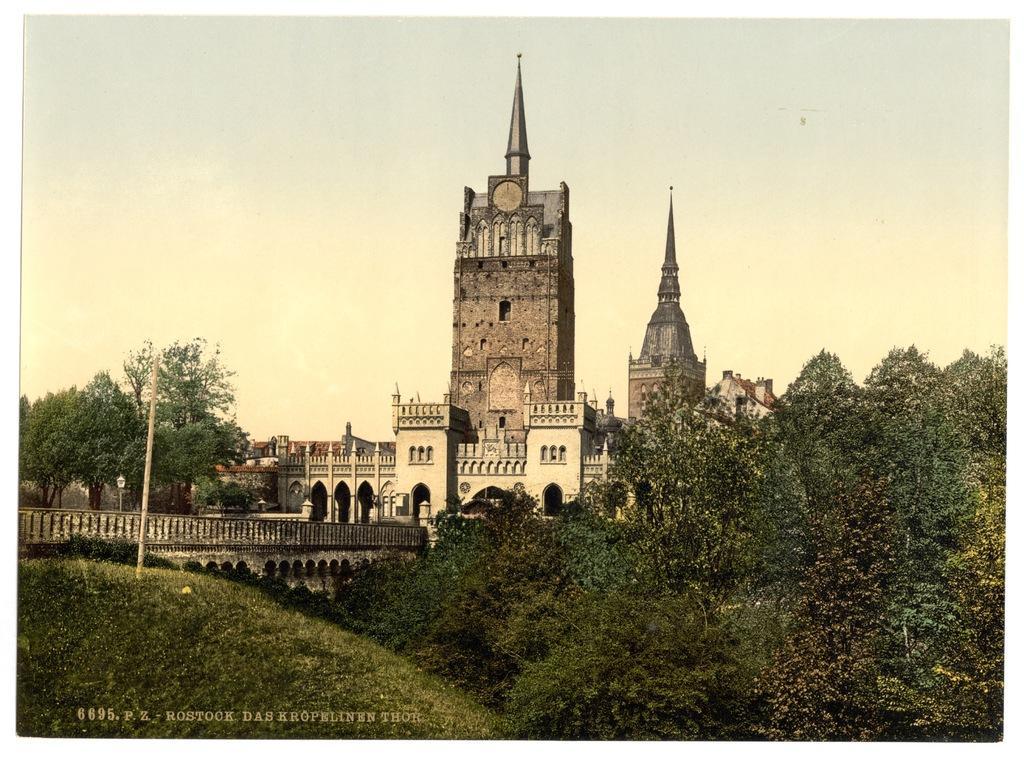Can you describe this image briefly? In this image we can see the buildings, there are some trees, poles and grass on the ground, also we can see a bridge, in the background, we can see the sky. 